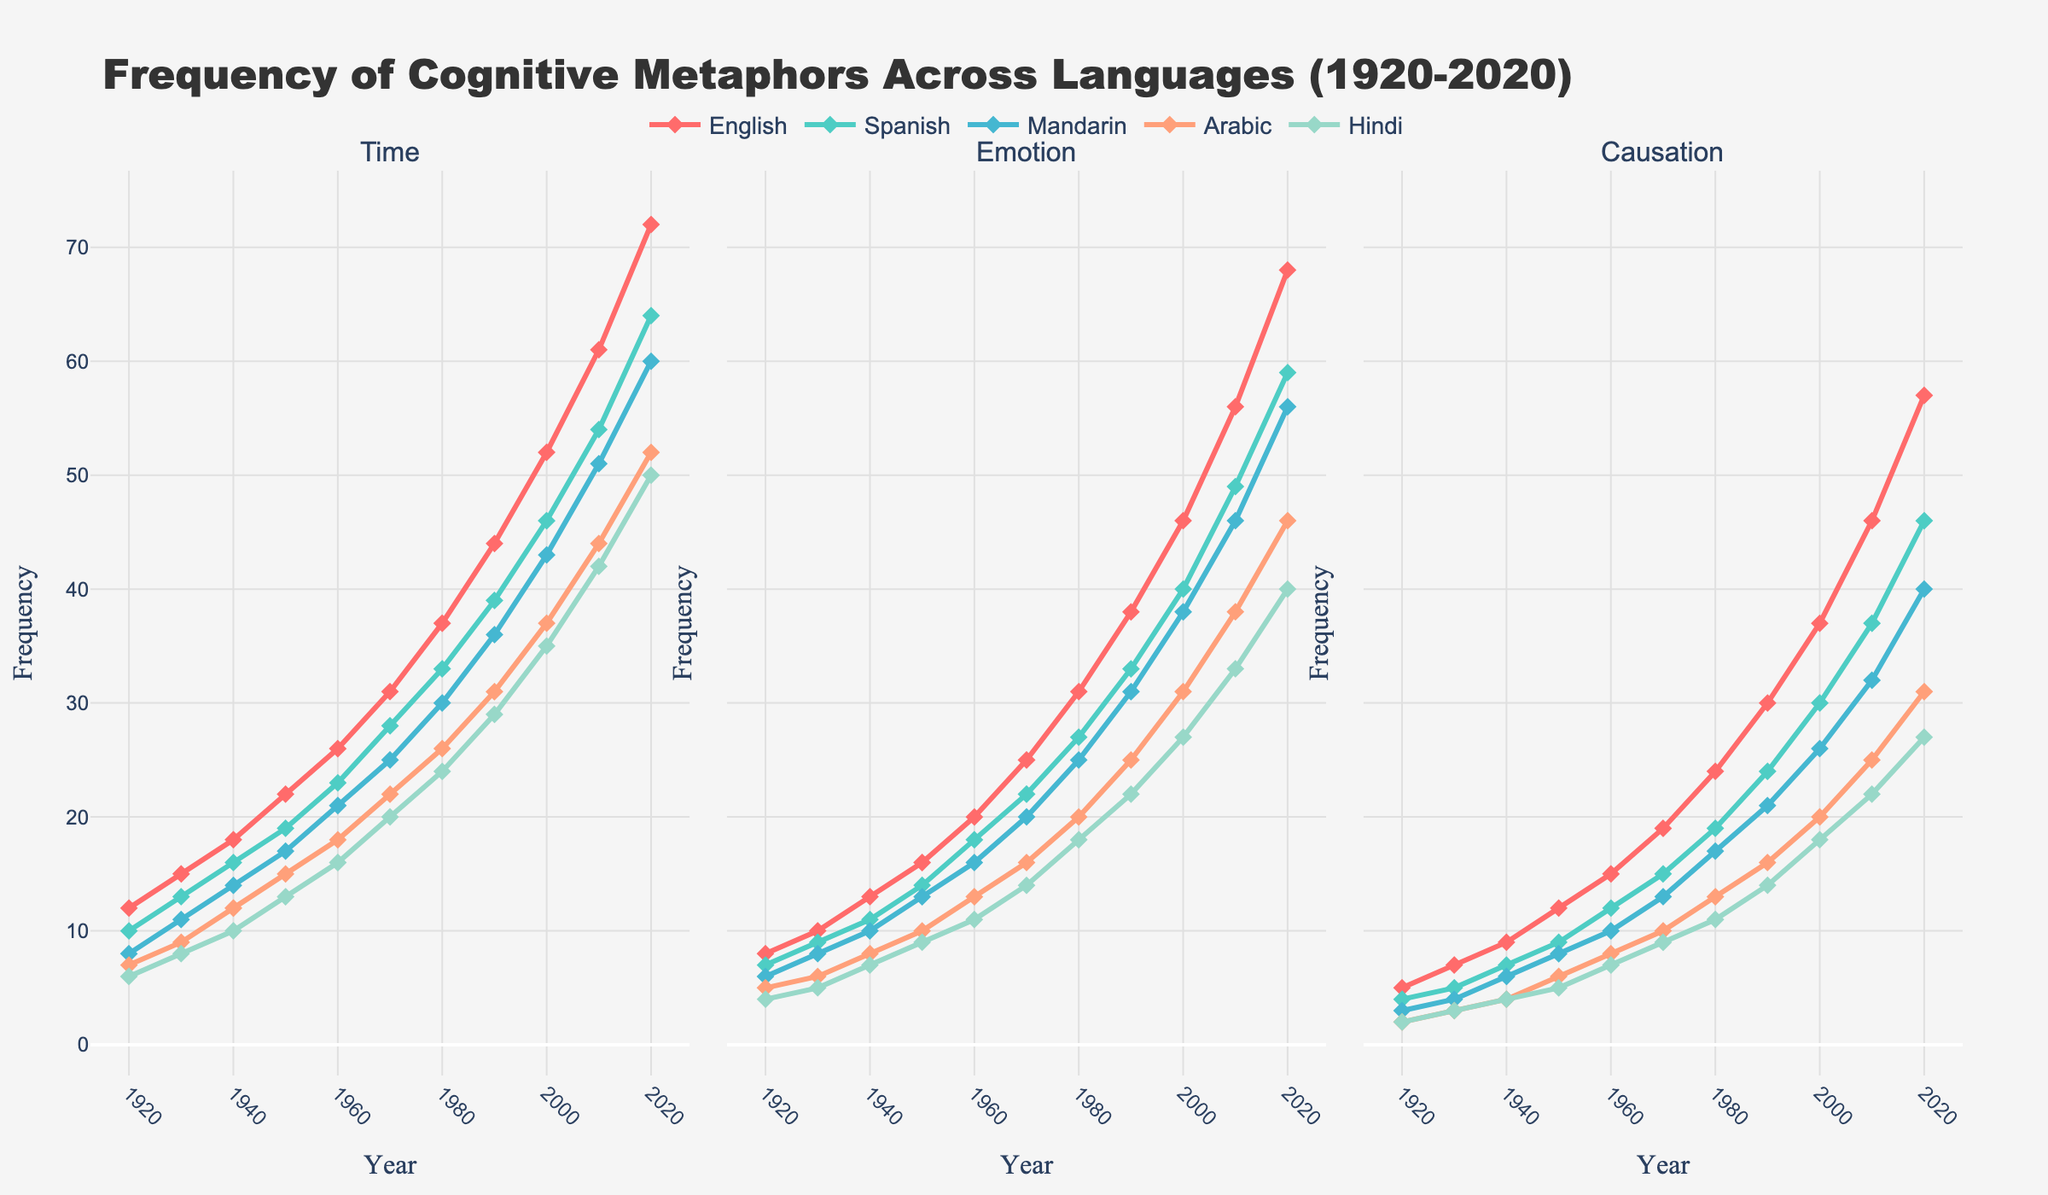Which language shows the highest frequency of the 'Time' metaphor in 2020? Look at the graph for the 'Time' metaphor in 2020 across all languages. The line representing English (colored red) reaches the highest point.
Answer: English Which abstract domain experienced the largest increase in frequency for English from 1920 to 2020? Compare the frequency values of English for each abstract domain in 1920 and 2020. The 'Time' metaphor increased from 12 to 72, a difference of 60, which is the largest increase.
Answer: Time How does the frequency of 'Emotion' metaphors in Spanish in 2020 compare to that in 1920? Look at the graph for 'Emotion' metaphors for Spanish in 1920 and 2020. In 1920, the frequency is 7, and in 2020, the frequency is 59.
Answer: The frequency in 2020 is 52 more than in 1920 Between 1960 and 1980, which abstract domain in Mandarin showed the highest rate of increase? Calculate the difference in frequencies for each abstract domain in Mandarin between 1960 and 1980. The 'Emotion' domain increased from 16 to 25, a difference of 9, which is the highest rate of increase among the domains.
Answer: Emotion Which abstract domain shows the smallest variability in frequency for Arabic from 1920 to 2020? Look at the trend lines for Arabic across all abstract domains from 1920 to 2020. The 'Causation' domain has the smallest overall range of change, indicating the least variability.
Answer: Causation What is the average frequency of the 'Causation' metaphor in Hindi over the entire period? Sum the frequencies of the 'Causation' metaphor in Hindi over all years and divide by the number of years. The sum is (2+3+4+5+7+9+11+14+18+22+27 = 122), and there are 11 years. 122/11 = 11.09
Answer: 11.09 Between 1920 and 2020, which language shows a consistent increase in frequency for all three abstract domains? Observe lines for all three abstract domains across all languages from 1920 to 2020. English shows a consistent increase in frequency for 'Time', 'Emotion', and 'Causation'.
Answer: English In 2020, which abstract domain has the lowest frequency of metaphors in Arabic? Check the frequency values for all abstract domains in Arabic in 2020. The 'Causation' domain has the lowest frequency value (31).
Answer: Causation 